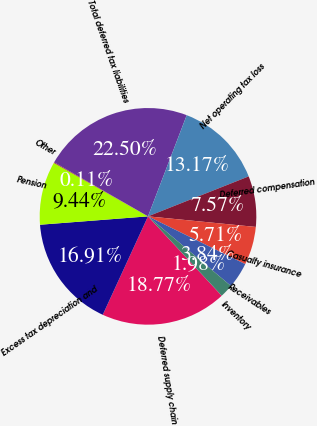Convert chart to OTSL. <chart><loc_0><loc_0><loc_500><loc_500><pie_chart><fcel>Deferred supply chain<fcel>Excess tax depreciation and<fcel>Pension<fcel>Other<fcel>Total deferred tax liabilities<fcel>Net operating tax loss<fcel>Deferred compensation<fcel>Casualty insurance<fcel>Receivables<fcel>Inventory<nl><fcel>18.77%<fcel>16.91%<fcel>9.44%<fcel>0.11%<fcel>22.5%<fcel>13.17%<fcel>7.57%<fcel>5.71%<fcel>3.84%<fcel>1.98%<nl></chart> 